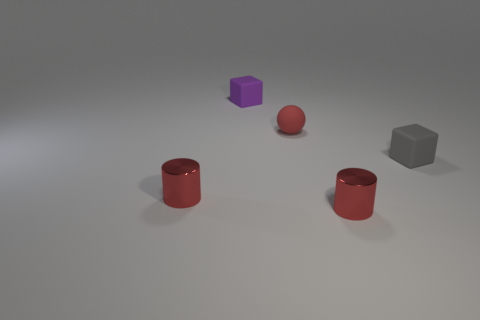How many cylinders are the same color as the rubber sphere?
Your response must be concise. 2. Are there fewer purple rubber things than big cyan things?
Your answer should be very brief. No. How many other objects are there of the same size as the red ball?
Your answer should be very brief. 4. The tiny metal thing left of the small red thing to the right of the tiny red rubber ball is what color?
Give a very brief answer. Red. How many other objects are the same shape as the tiny gray rubber thing?
Provide a short and direct response. 1. Are there any tiny gray blocks made of the same material as the tiny purple object?
Your answer should be very brief. Yes. There is a matte cube that is left of the tiny block in front of the object behind the ball; what color is it?
Give a very brief answer. Purple. There is a red thing that is behind the tiny gray thing; is its shape the same as the purple object behind the matte sphere?
Your answer should be very brief. No. What number of tiny yellow objects are there?
Offer a terse response. 0. What color is the rubber cube that is the same size as the purple matte thing?
Give a very brief answer. Gray. 